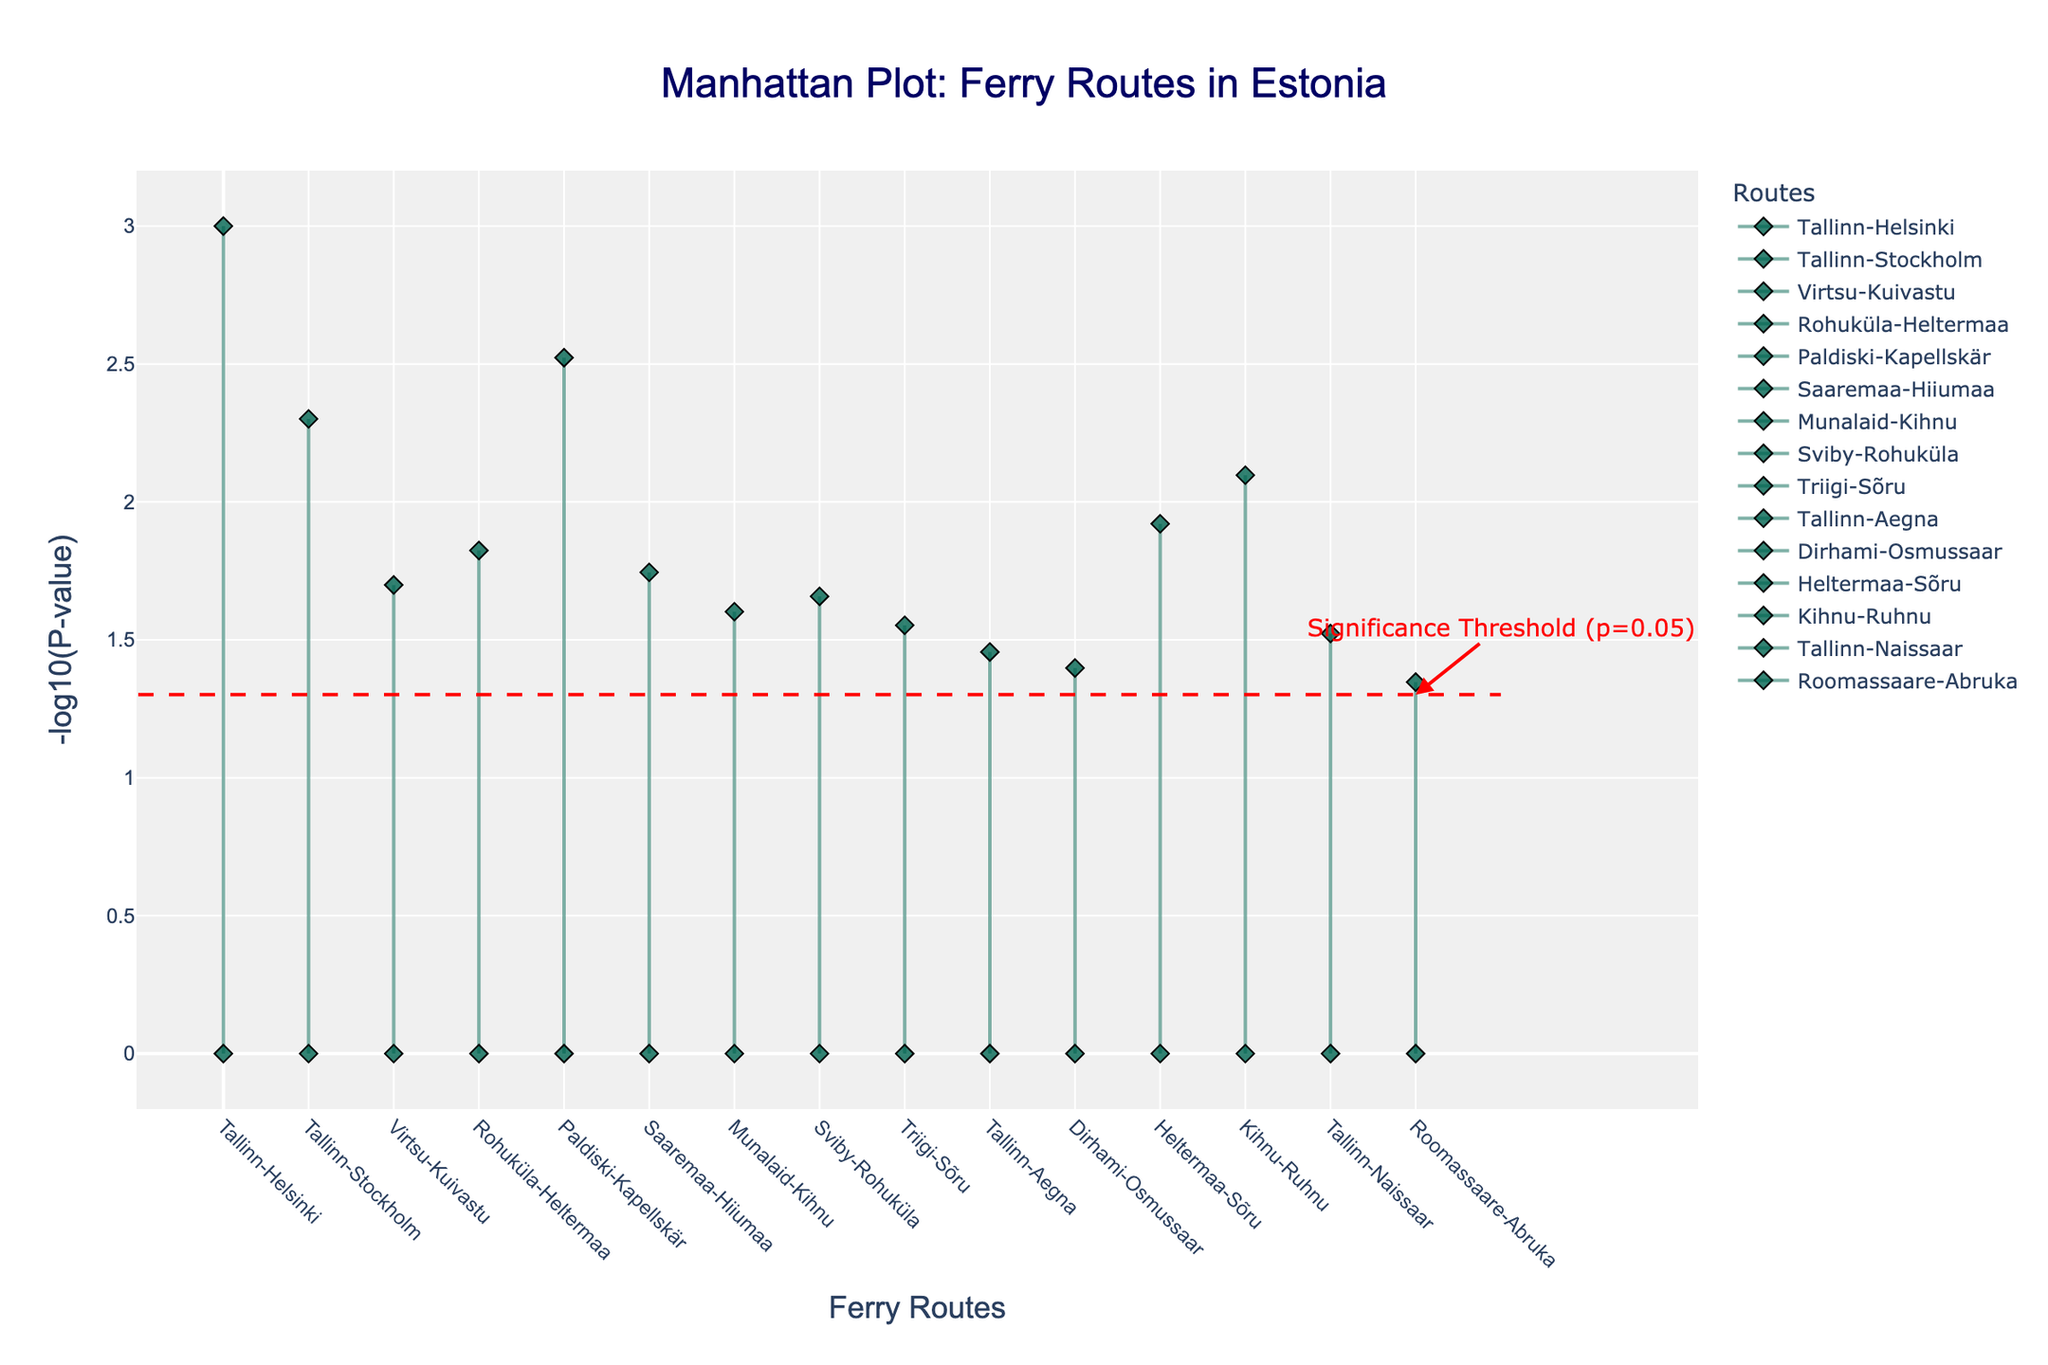What is the title of the Manhattan Plot? The title is positioned at the top of the plot, typically summarizing what the plot represents. In this case, the title reads, "Manhattan Plot: Ferry Routes in Estonia."
Answer: Manhattan Plot: Ferry Routes in Estonia How is the y-axis labeled on the plot? The y-axis label is placed along the vertical axis and explains the metric used. Here, it is labeled as '-log10(P-value).'
Answer: -log10(P-value) Which ferry route represents the highest value on the y-axis? The highest value on the y-axis indicates the most statistically significant correlation. The ferry route at this peak can be identified from the scatter plot. It's the "Tallinn-Helsinki" route, with a -log10(P-value) corresponding to 0.001 (significantly low p-value).
Answer: Tallinn-Helsinki How many ferry routes have a p-value less than 0.05? Ferry routes with points above the red significance threshold line (-log10(0.05) = 1.301) are considered significant. Count the number of points above this line. There are 11 such points.
Answer: 11 What color and shape represent the data points for the ferry routes in this plot? Observing the legend and the points, they are represented by diamond shapes with a color combination of green and black edges.
Answer: Diamond shapes in green with black edges What is the threshold of significance as marked in the plot, and how is it visually represented? The threshold of significance is set at a p-value of 0.05, represented visually by a red dashed horizontal line.
Answer: p-value of 0.05, red dashed horizontal line Which ferry route has the lowest -log10(P-value) on the plot? The lowest -log10(P-value) corresponds to the least statistically significant route. The "Roomassaare-Abruka" route shows a value just at -log10(0.045).
Answer: Roomassaare-Abruka Which ferry routes have a distance equal to or less than 10 km, and their significance levels? Refer to the hover information or x-axis labels for routes with distances equal to or less than 10 km: "Virtsu-Kuivastu," "Dirhami-Osmussaar," and "Roomassaare-Abruka." Their respective p-values are 0.02, 0.04, and 0.045, all of which are below the horizontal red dashed line, indicating statistical significance.
Answer: Virtsu-Kuivastu, Dirhami-Osmussaar, Roomassaare-Abruka with p-values 0.02, 0.04, and 0.045 Between the "Tallinn-Helsinki" and "Tallinn-Stockholm" routes, which one is more statistically significant? Compare their -log10(P-value) on the plot. "Tallinn-Helsinki" has a lower p-value (0.001) than "Tallinn-Stockholm" (0.005), making it more statistically significant.
Answer: Tallinn-Helsinki What is the average price of all ferry routes shown in the plot? Sum the prices of all routes and divide by the number of routes. Prices: 25, 45, 3, 7, 35, 8, 6, 7, 6, 5, 4, 9, 15, 6, 3. Average = (25+45+3+7+35+8+6+7+6+5+4+9+15+6+3) / 15 = 13.2
Answer: 13.2 